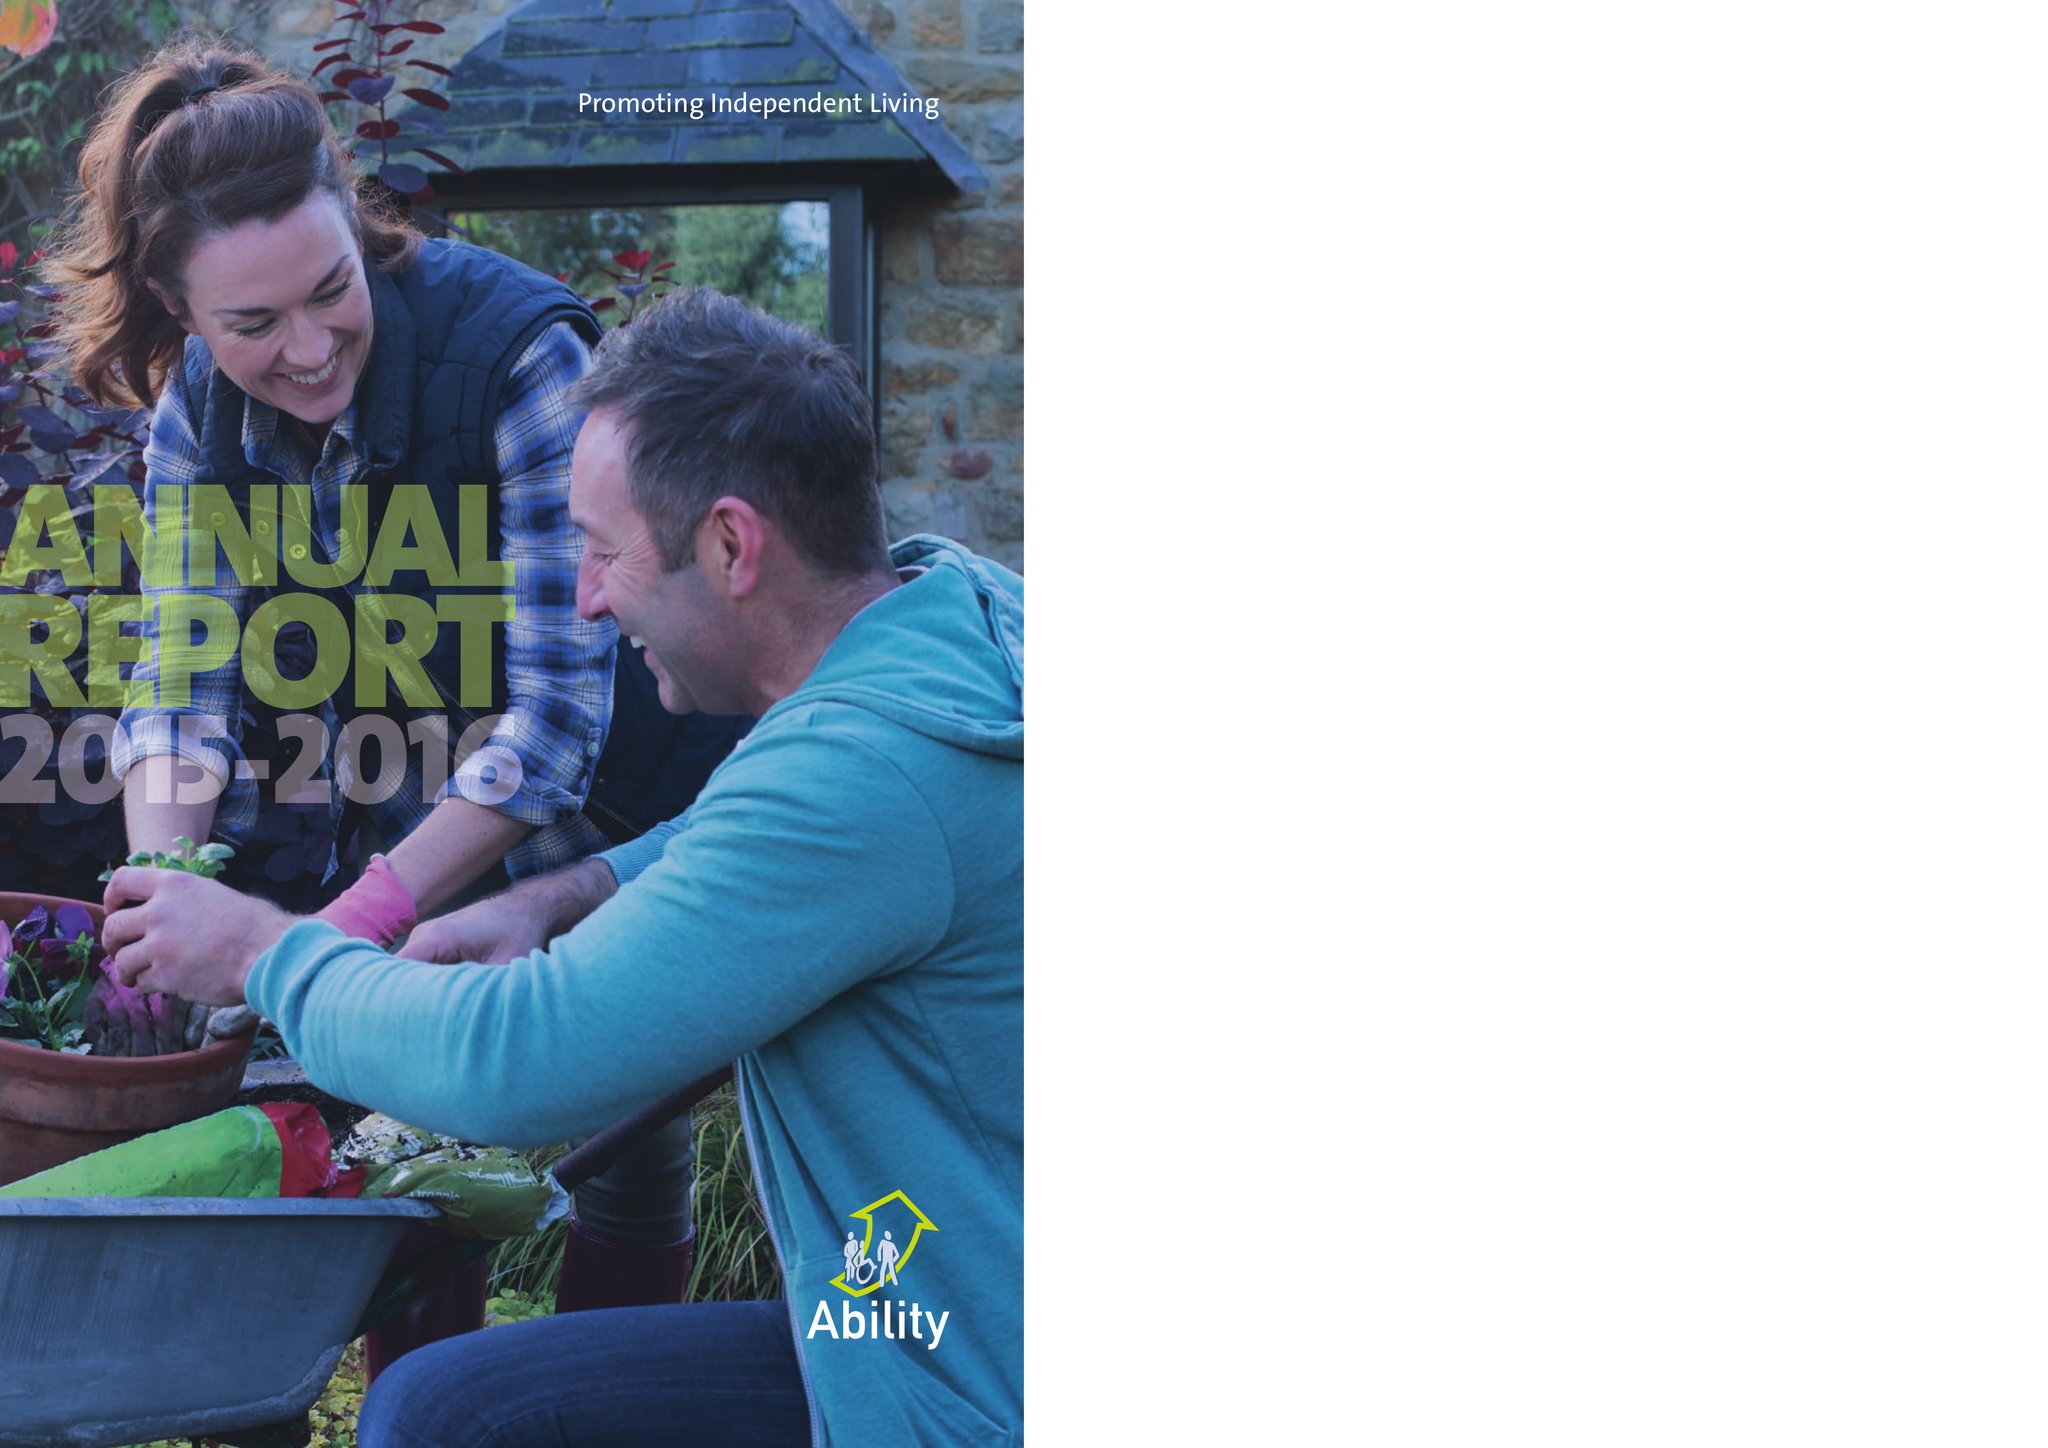What is the value for the report_date?
Answer the question using a single word or phrase. 2016-09-30 